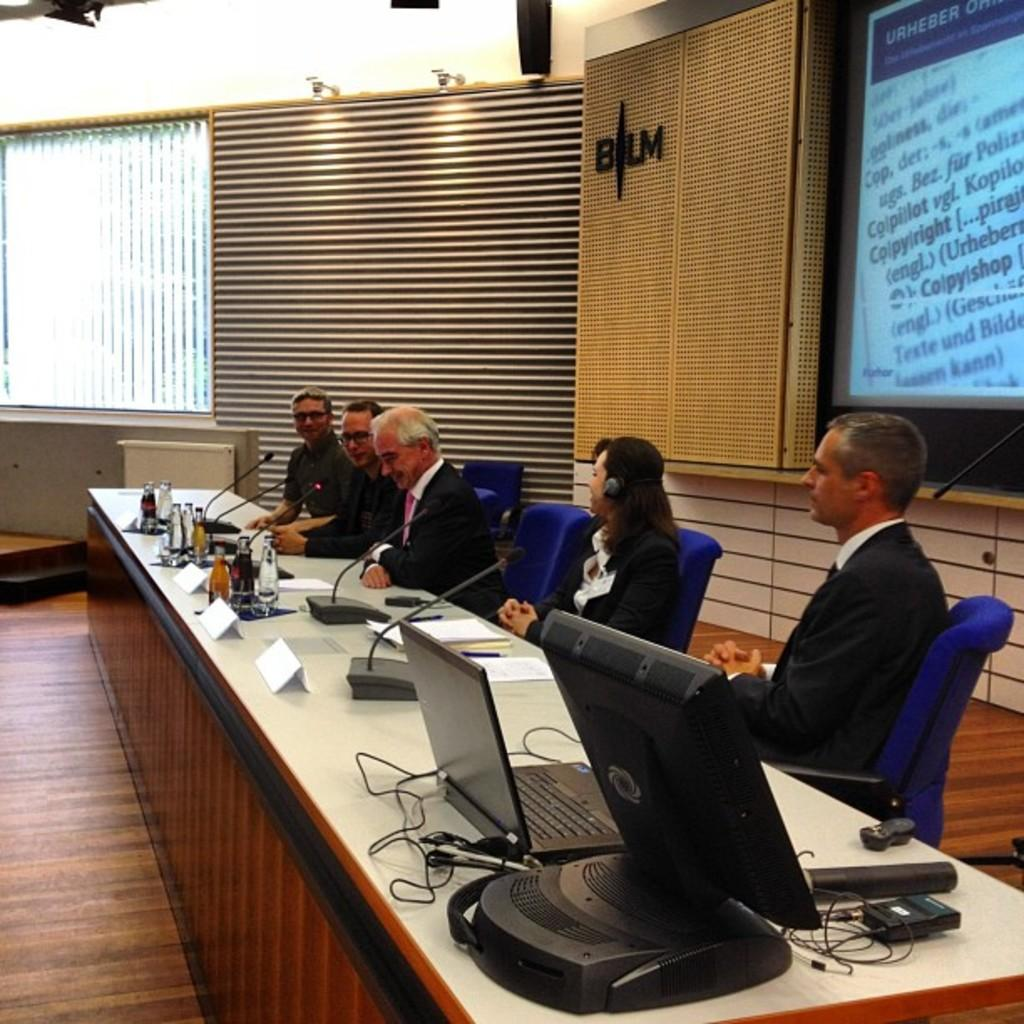<image>
Summarize the visual content of the image. 5 people in suits are sitting at a panel in front of a BLM logo. 